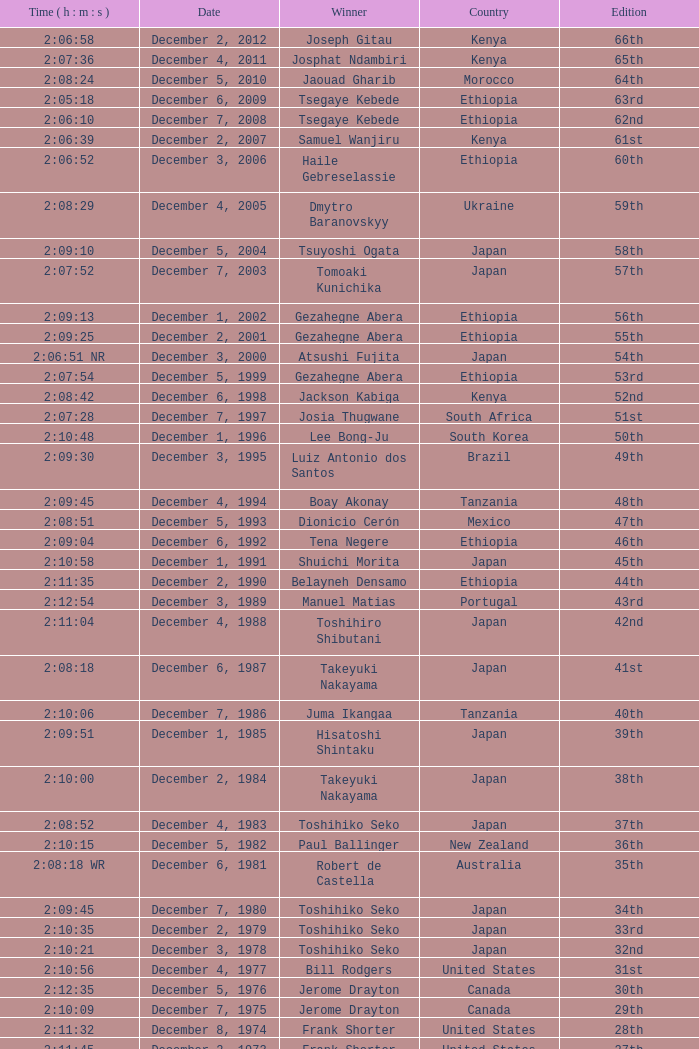On what date did Lee Bong-Ju win in 2:10:48? December 1, 1996. 